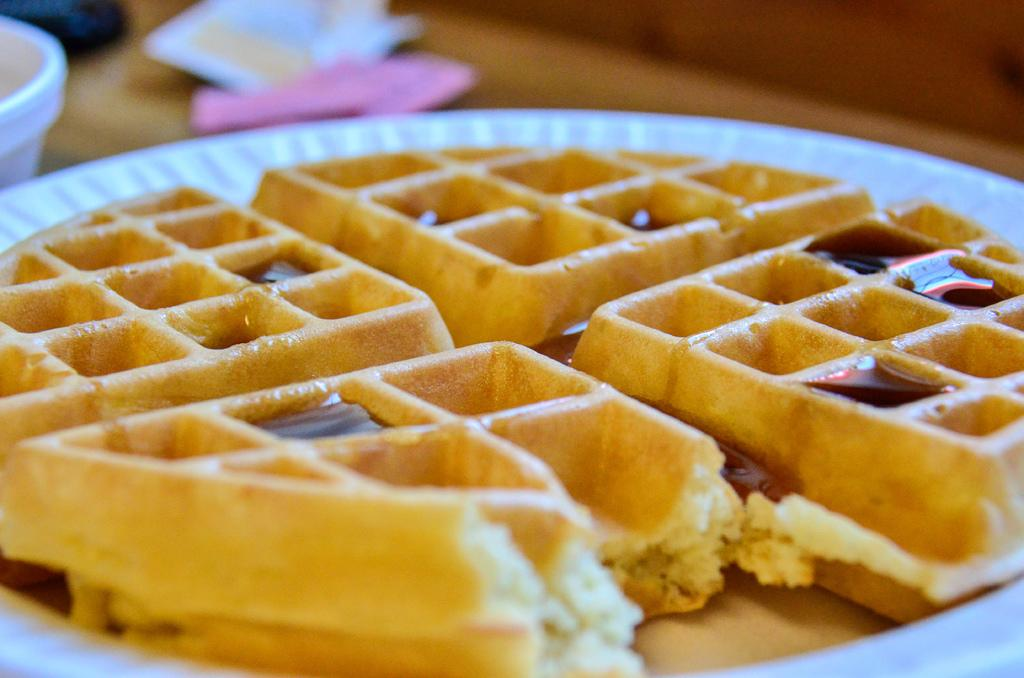What is located in the left corner of the image? There is a bowl in the left corner of the image. What is inside the bowl? There is a food item in the bowl. How many nails can be seen in the image? There are no nails present in the image. What type of plough is being used to prepare the food in the bowl? There is no plough present in the image, and the food item in the bowl does not require ploughing. 